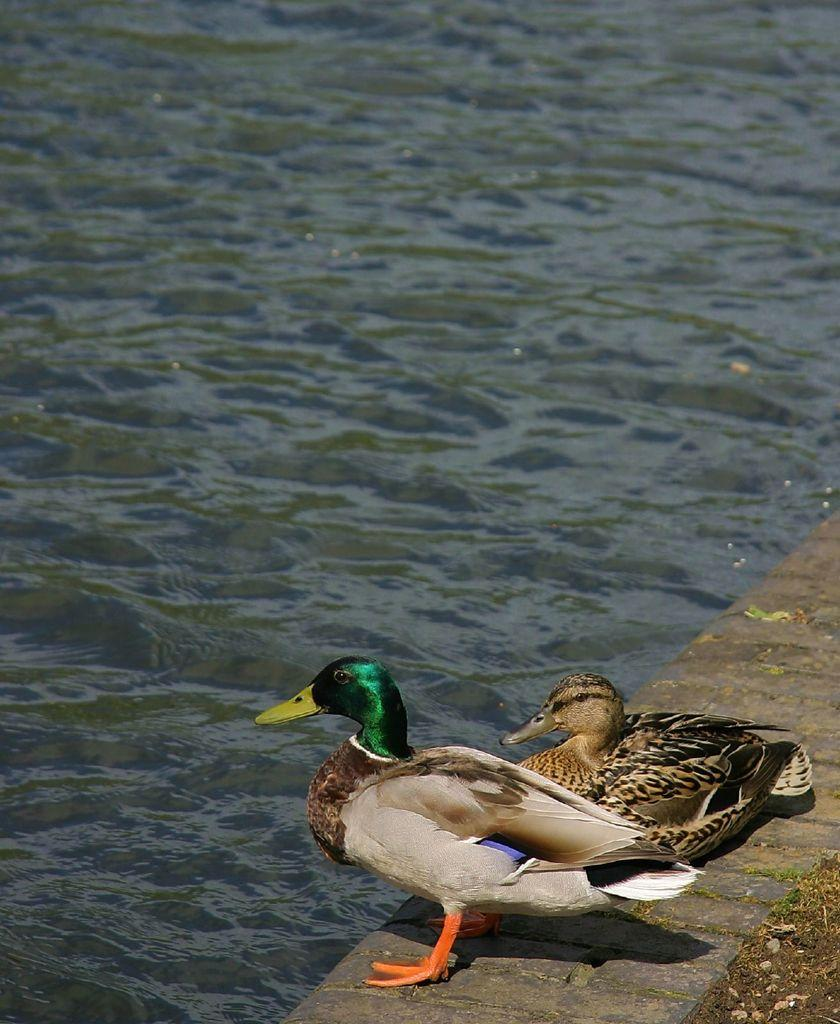What animals are present in the image? There are two ducks in the image. Where are the ducks located in the image? The ducks are at the bottom side of the image. What is the primary element surrounding the ducks? There is water visible in the image. What type of wall can be seen supporting the ducks in the image? There is no wall present in the image, and the ducks are not being supported by any structure. 